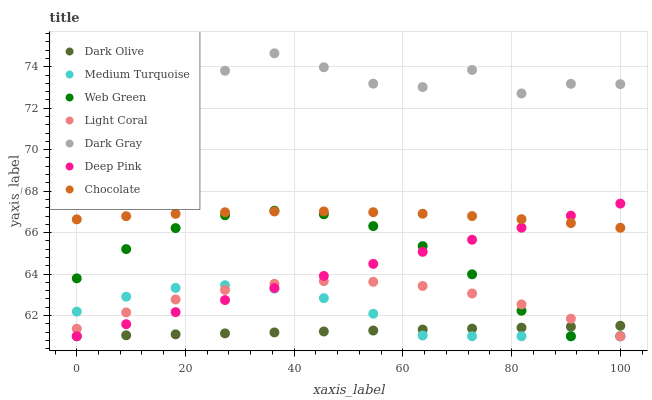Does Dark Olive have the minimum area under the curve?
Answer yes or no. Yes. Does Dark Gray have the maximum area under the curve?
Answer yes or no. Yes. Does Deep Pink have the minimum area under the curve?
Answer yes or no. No. Does Deep Pink have the maximum area under the curve?
Answer yes or no. No. Is Deep Pink the smoothest?
Answer yes or no. Yes. Is Dark Gray the roughest?
Answer yes or no. Yes. Is Dark Olive the smoothest?
Answer yes or no. No. Is Dark Olive the roughest?
Answer yes or no. No. Does Deep Pink have the lowest value?
Answer yes or no. Yes. Does Chocolate have the lowest value?
Answer yes or no. No. Does Dark Gray have the highest value?
Answer yes or no. Yes. Does Deep Pink have the highest value?
Answer yes or no. No. Is Deep Pink less than Dark Gray?
Answer yes or no. Yes. Is Dark Gray greater than Dark Olive?
Answer yes or no. Yes. Does Chocolate intersect Deep Pink?
Answer yes or no. Yes. Is Chocolate less than Deep Pink?
Answer yes or no. No. Is Chocolate greater than Deep Pink?
Answer yes or no. No. Does Deep Pink intersect Dark Gray?
Answer yes or no. No. 